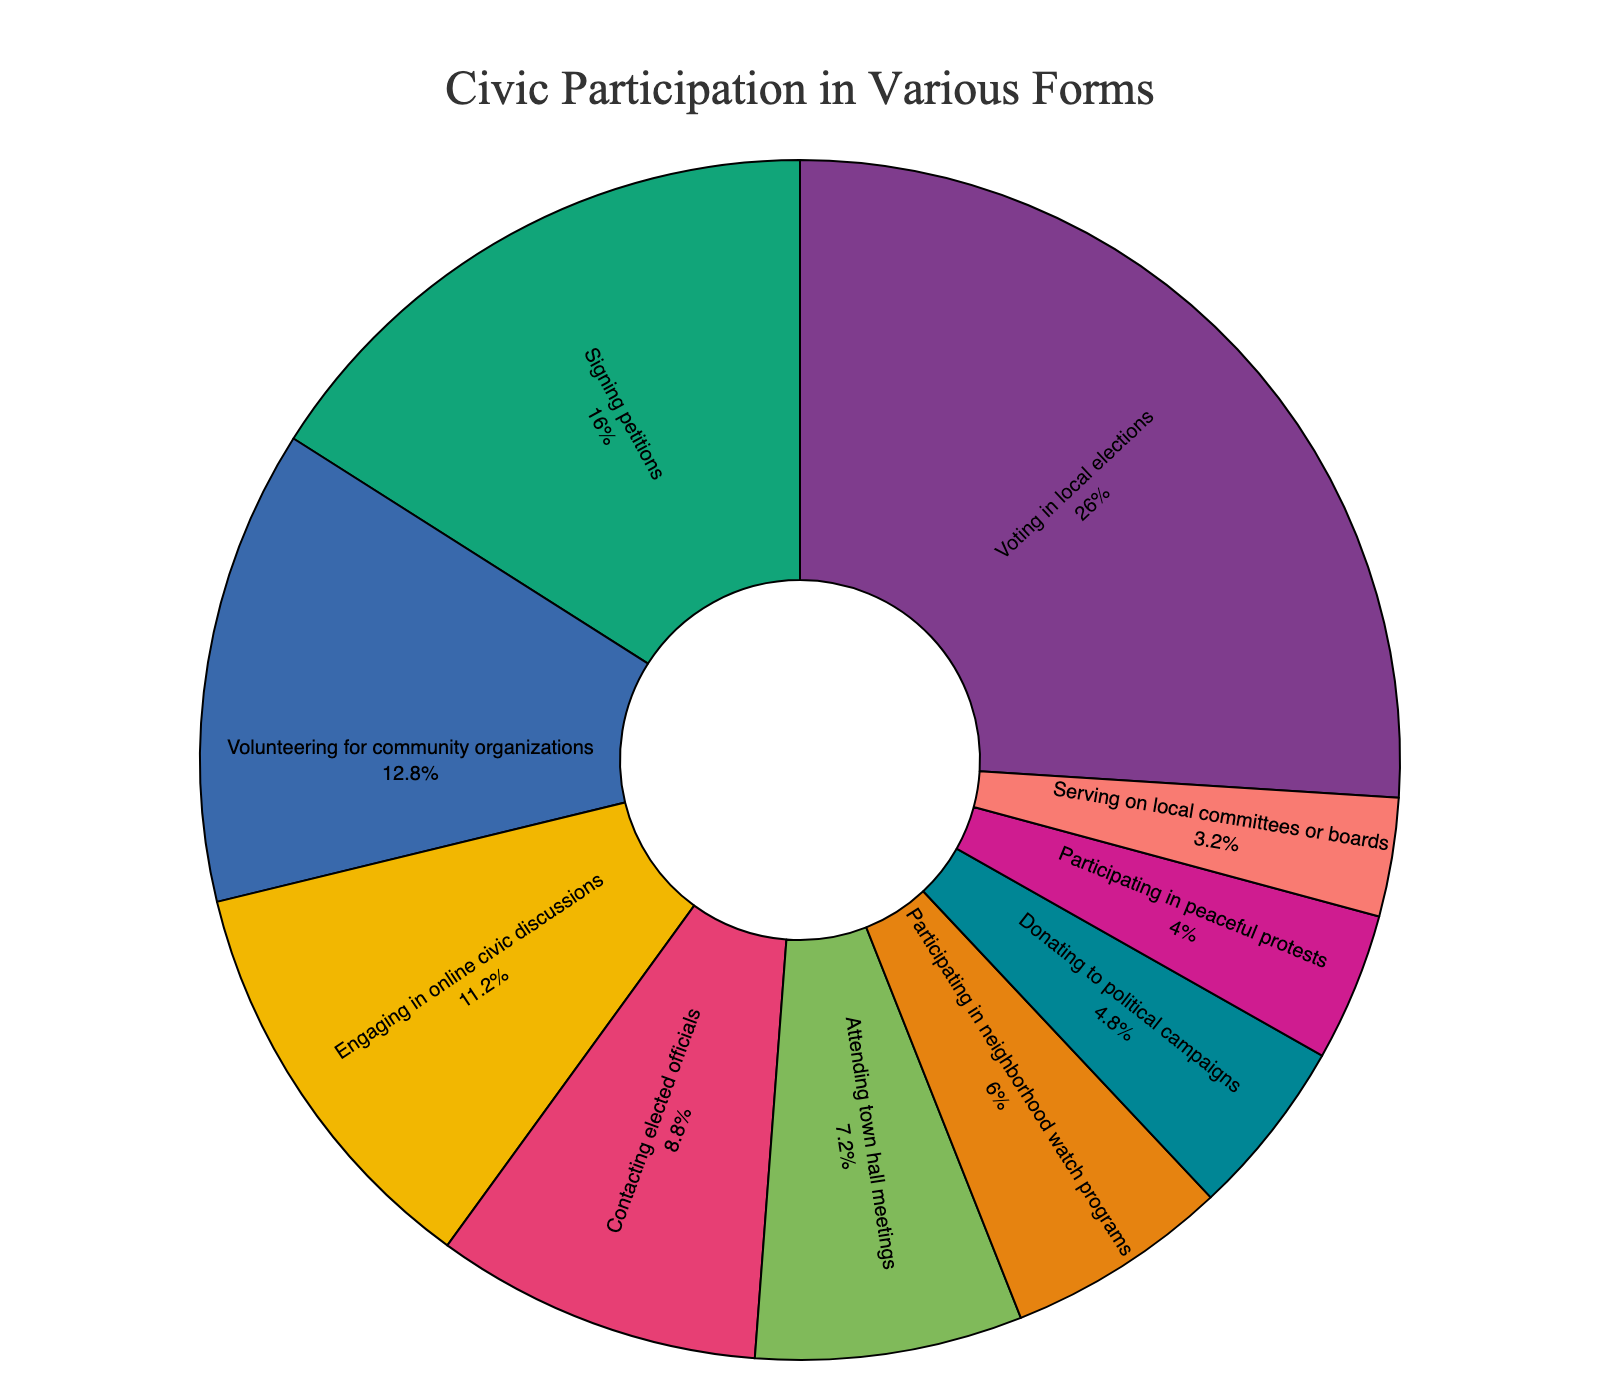What percentage of citizens participate in signing petitions? The slice labeled "Signing petitions" shows the percentage directly.
Answer: 40% Which form of civic participation has the lowest engagement? The slice with the smallest percentage value represents the lowest engagement.
Answer: Serving on local committees or boards What is the difference in percentage between volunteering for community organizations and engaging in online civic discussions? The percentage of "Volunteering for community organizations" is 32%, and "Engaging in online civic discussions" is 28%. Find the difference: 32% - 28%.
Answer: 4% Which form of civic participation has a higher engagement: contacting elected officials or participating in peaceful protests? Compare the percentages of "Contacting elected officials" (22%) and "Participating in peaceful protests" (10%).
Answer: Contacting elected officials If you combine the percentages of participating in neighborhood watch programs and attending town hall meetings, what is the total percentage? The percentages are 15% for "Participating in neighborhood watch programs" and 18% for "Attending town hall meetings". Sum them up: 15% + 18%.
Answer: 33% Which color represents citizens engaging in online civic discussions, and what is the percentage? Look for the slice labeled "Engaging in online civic discussions" to identify its color and percentage.
Answer: Pastel color, 28% Is the percentage of voters in local elections greater than the percentage of those who sign petitions and attend town hall meetings combined? Voting in local elections is 65%. Adding "Signing petitions" (40%) and "Attending town hall meetings" (18%) gives 58%. Compare: 65% > 58%.
Answer: Yes What is the combined percentage for the three least participated forms of civic engagement? The least engaged activities are "Serving on local committees or boards" (8%), "Participating in peaceful protests" (10%), and "Donating to political campaigns" (12%). Sum: 8% + 10% + 12%.
Answer: 30% How many forms of civic participation have an engagement percentage below 20%? Identify the slices with percentages below 20%: "Serving on local committees or boards" (8%), "Participating in peaceful protests" (10%), "Donating to political campaigns" (12%), "Participating in neighborhood watch programs" (15%), "Attending town hall meetings" (18%). Count them.
Answer: 5 